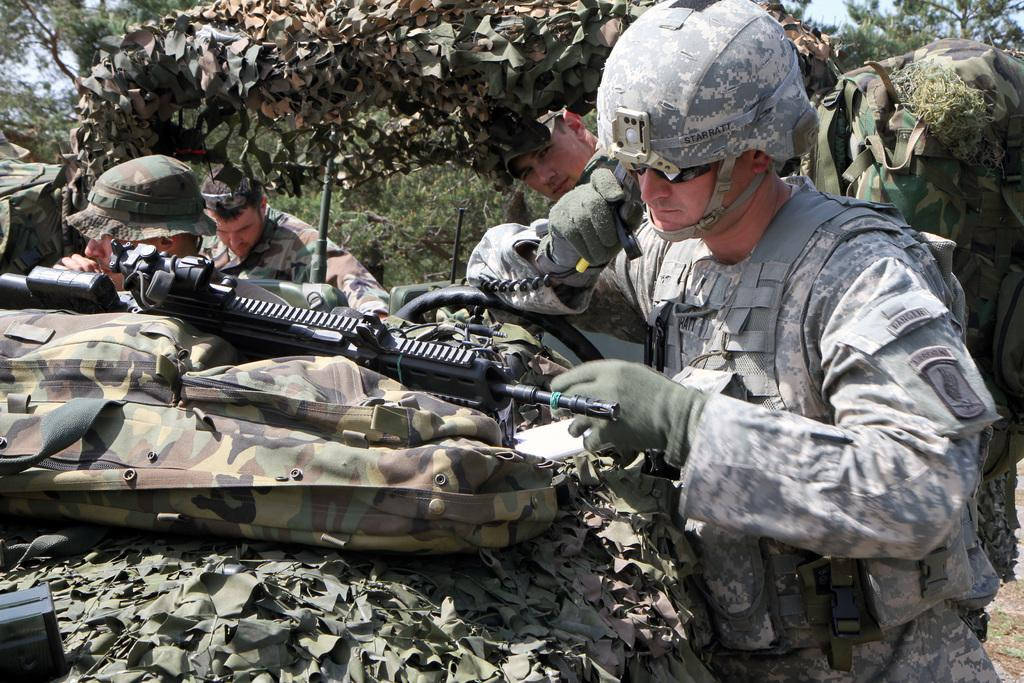What type of figures are in the middle of the image? There are army men in the image. What are the army men holding in the image? There are weapons in the image. Where is the bag located in the image? The bag is on the left side of the image. What can be seen in the background of the image? There are trees in the background of the image. What type of branch is the bird holding in the image? There is no bird or branch present in the image. 